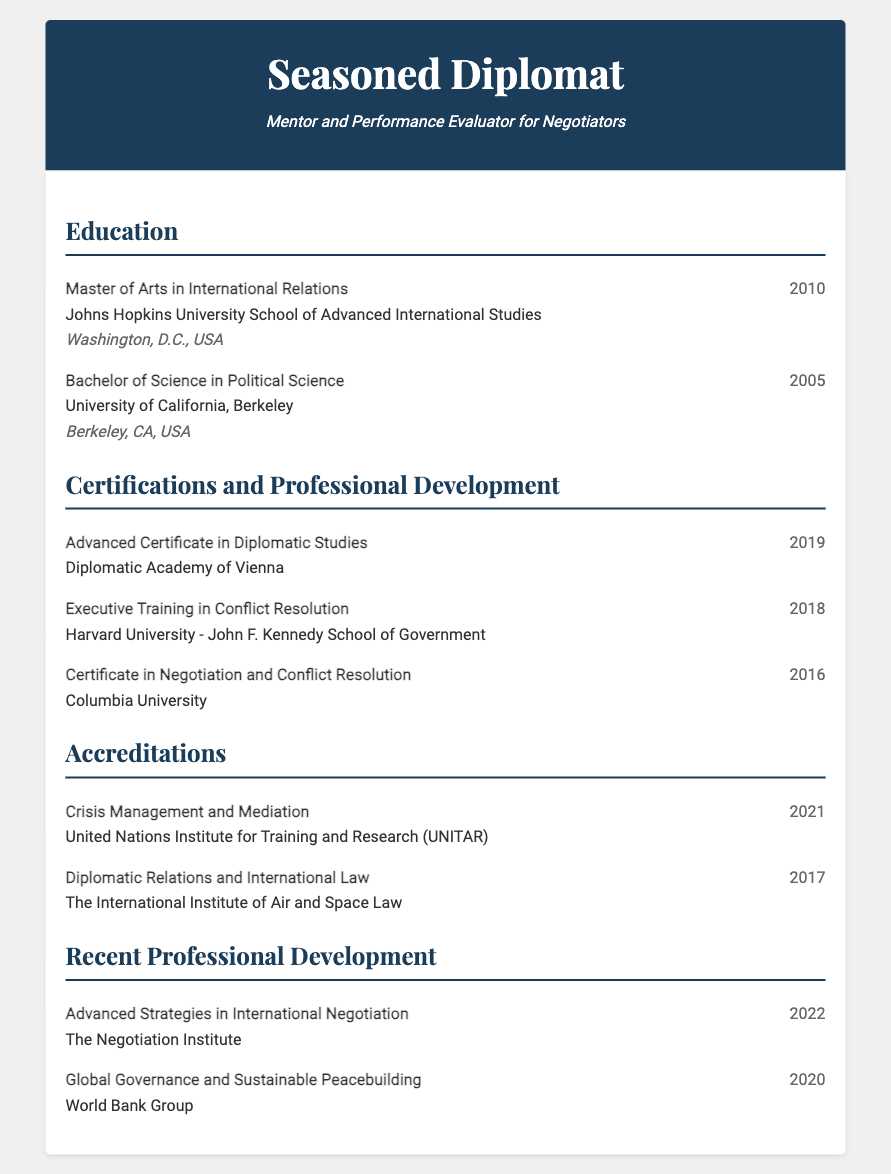What degree was obtained in 2010? The document lists the degree received in that year as a Master of Arts in International Relations.
Answer: Master of Arts in International Relations Which university awarded the Bachelor of Science degree? The document states that the Bachelor of Science was obtained from the University of California, Berkeley.
Answer: University of California, Berkeley What year was the Advanced Certificate in Diplomatic Studies obtained? The document specifies that this certification was earned in 2019.
Answer: 2019 Which institution provided the training in Conflict Resolution in 2018? The document indicates that Harvard University - John F. Kennedy School of Government offered this training.
Answer: Harvard University - John F. Kennedy School of Government What is the focus of the accreditation received from UNITAR in 2021? The document describes this accreditation as relating to Crisis Management and Mediation.
Answer: Crisis Management and Mediation How many certifications or accreditations are listed in the document? The document outlines a total of 5 certifications and accreditations.
Answer: 5 What recent professional development occurred in 2022? The document states that Advanced Strategies in International Negotiation was conducted in that year.
Answer: Advanced Strategies in International Negotiation What location is associated with the Johns Hopkins University? The document mentions Washington, D.C., USA as the location for this university.
Answer: Washington, D.C., USA Which year did the individual complete the Certificate in Negotiation and Conflict Resolution? The document provides that this certification was completed in 2016.
Answer: 2016 